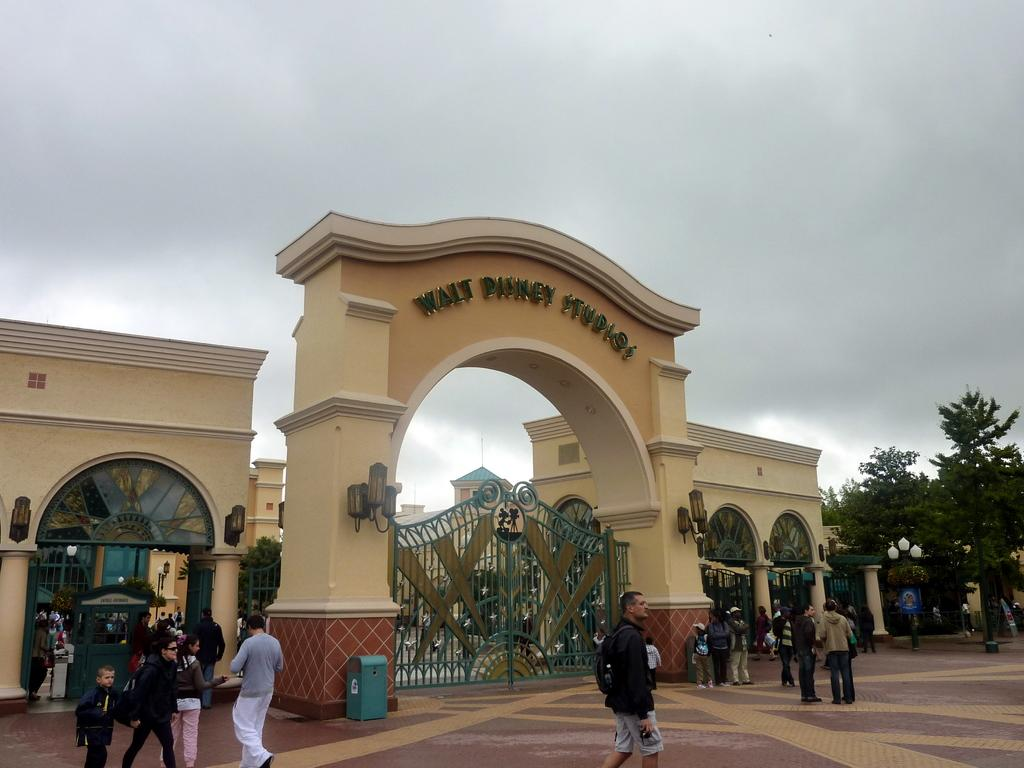<image>
Relay a brief, clear account of the picture shown. Guests are arriving at the gates of Walt Disney Studios. 